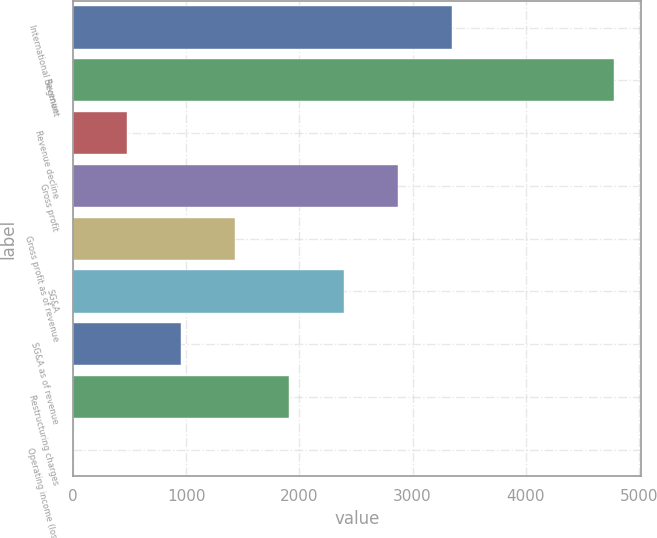Convert chart. <chart><loc_0><loc_0><loc_500><loc_500><bar_chart><fcel>International Segment<fcel>Revenue<fcel>Revenue decline<fcel>Gross profit<fcel>Gross profit as of revenue<fcel>SG&A<fcel>SG&A as of revenue<fcel>Restructuring charges<fcel>Operating income (loss)<nl><fcel>3346.3<fcel>4780<fcel>478.9<fcel>2868.4<fcel>1434.7<fcel>2390.5<fcel>956.8<fcel>1912.6<fcel>1<nl></chart> 